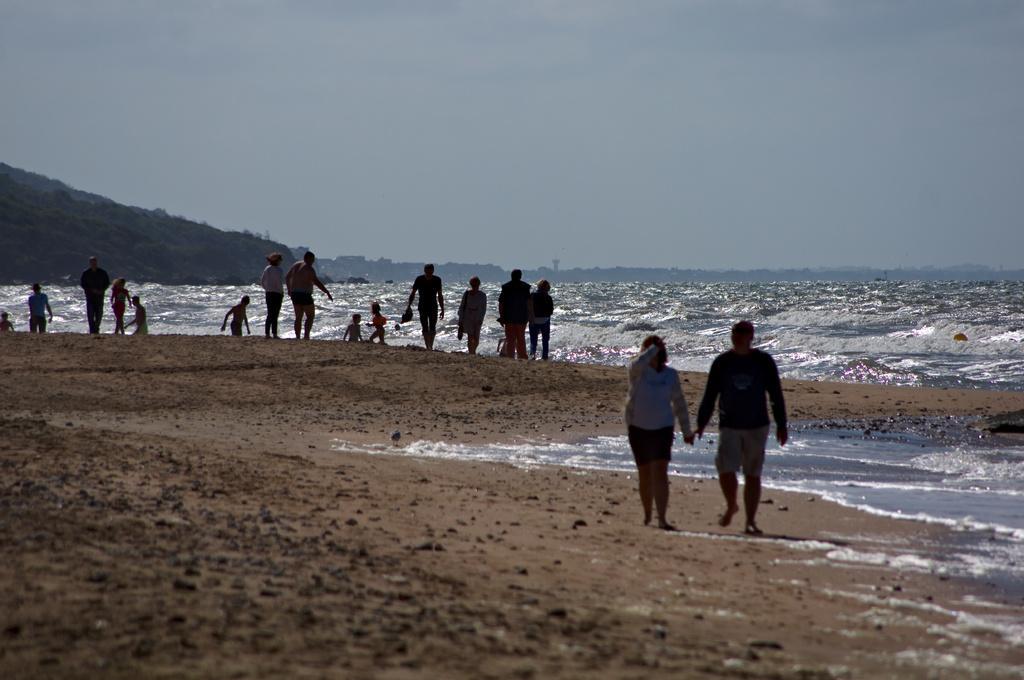In one or two sentences, can you explain what this image depicts? In this image there are group of people standing , there is water , hill, and in the background there is sky. 